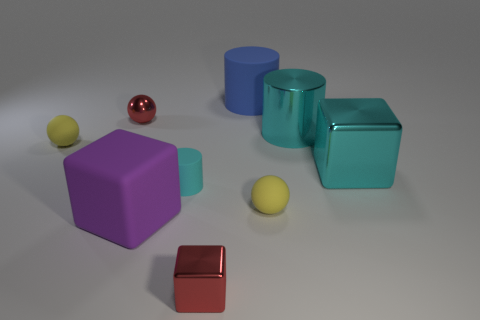Subtract all shiny cylinders. How many cylinders are left? 2 Subtract all cylinders. How many objects are left? 6 Add 1 big matte cylinders. How many objects exist? 10 Subtract 2 cylinders. How many cylinders are left? 1 Subtract all red cylinders. Subtract all cyan spheres. How many cylinders are left? 3 Subtract all purple cylinders. How many gray balls are left? 0 Subtract all large green blocks. Subtract all red shiny spheres. How many objects are left? 8 Add 1 big purple rubber blocks. How many big purple rubber blocks are left? 2 Add 2 red metallic blocks. How many red metallic blocks exist? 3 Subtract all cyan cubes. How many cubes are left? 2 